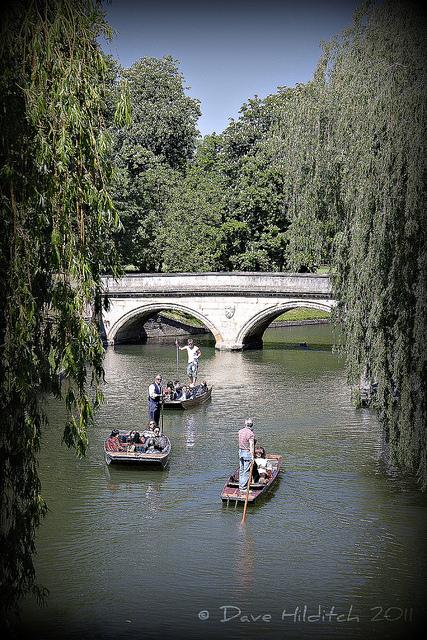Can the boats go underneath the bridge?
Be succinct. Yes. Do these boats have motors?
Give a very brief answer. No. What kind of boats are these?
Quick response, please. Rowboats. 